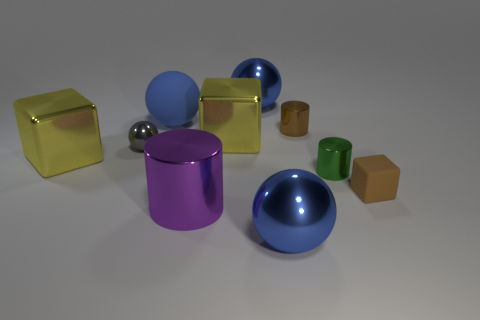Subtract all cylinders. How many objects are left? 7 Subtract all yellow blocks. How many blocks are left? 1 Subtract 2 cubes. How many cubes are left? 1 Subtract all brown blocks. How many cyan spheres are left? 0 Subtract all purple cubes. Subtract all tiny metallic spheres. How many objects are left? 9 Add 7 large blue metal balls. How many large blue metal balls are left? 9 Add 9 large green metal blocks. How many large green metal blocks exist? 9 Subtract all brown cylinders. How many cylinders are left? 2 Subtract 0 cyan balls. How many objects are left? 10 Subtract all green cubes. Subtract all purple spheres. How many cubes are left? 3 